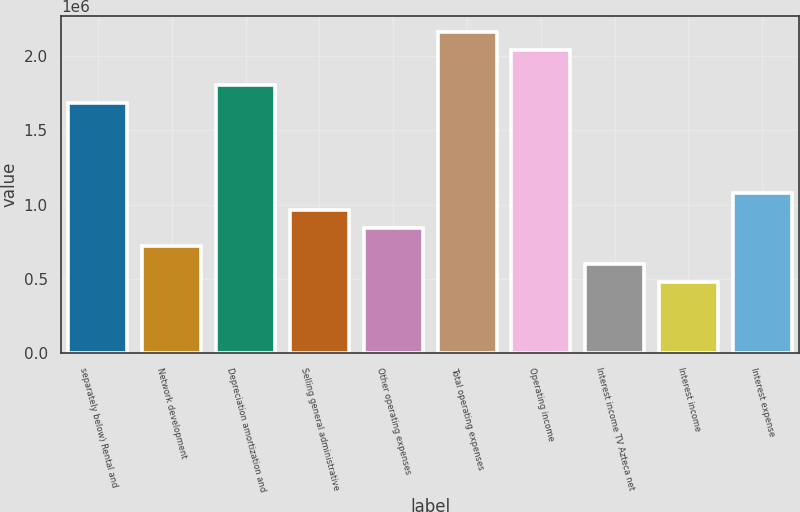Convert chart. <chart><loc_0><loc_0><loc_500><loc_500><bar_chart><fcel>separately below) Rental and<fcel>Network development<fcel>Depreciation amortization and<fcel>Selling general administrative<fcel>Other operating expenses<fcel>Total operating expenses<fcel>Operating income<fcel>Interest income TV Azteca net<fcel>Interest income<fcel>Interest expense<nl><fcel>1.68134e+06<fcel>720575<fcel>1.80144e+06<fcel>960766<fcel>840670<fcel>2.16172e+06<fcel>2.04163e+06<fcel>600479<fcel>480383<fcel>1.08086e+06<nl></chart> 